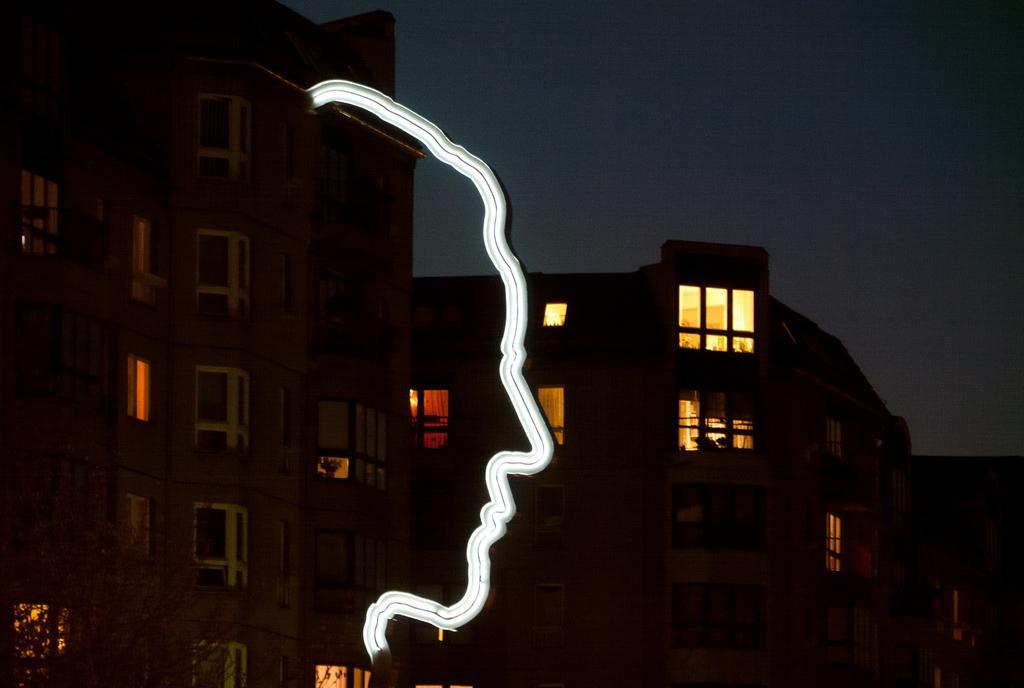Can you describe this image briefly? In this image I can see a white colour thing in the centre. I can also see few buildings, number of windows and on the bottom left side of this image I can see a tree. I can also see this image is little bit in dark. 